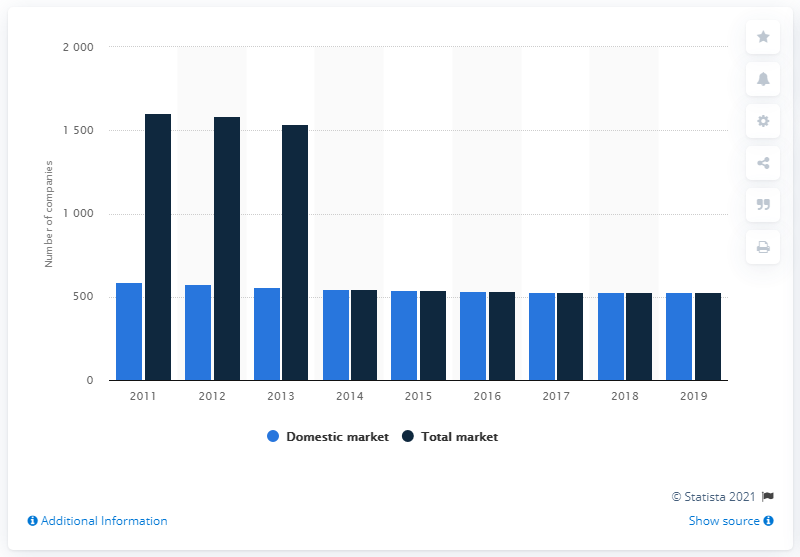Outline some significant characteristics in this image. In 2019, there were 530 domestic insurance companies operating in Germany. 